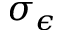Convert formula to latex. <formula><loc_0><loc_0><loc_500><loc_500>\sigma _ { \epsilon }</formula> 